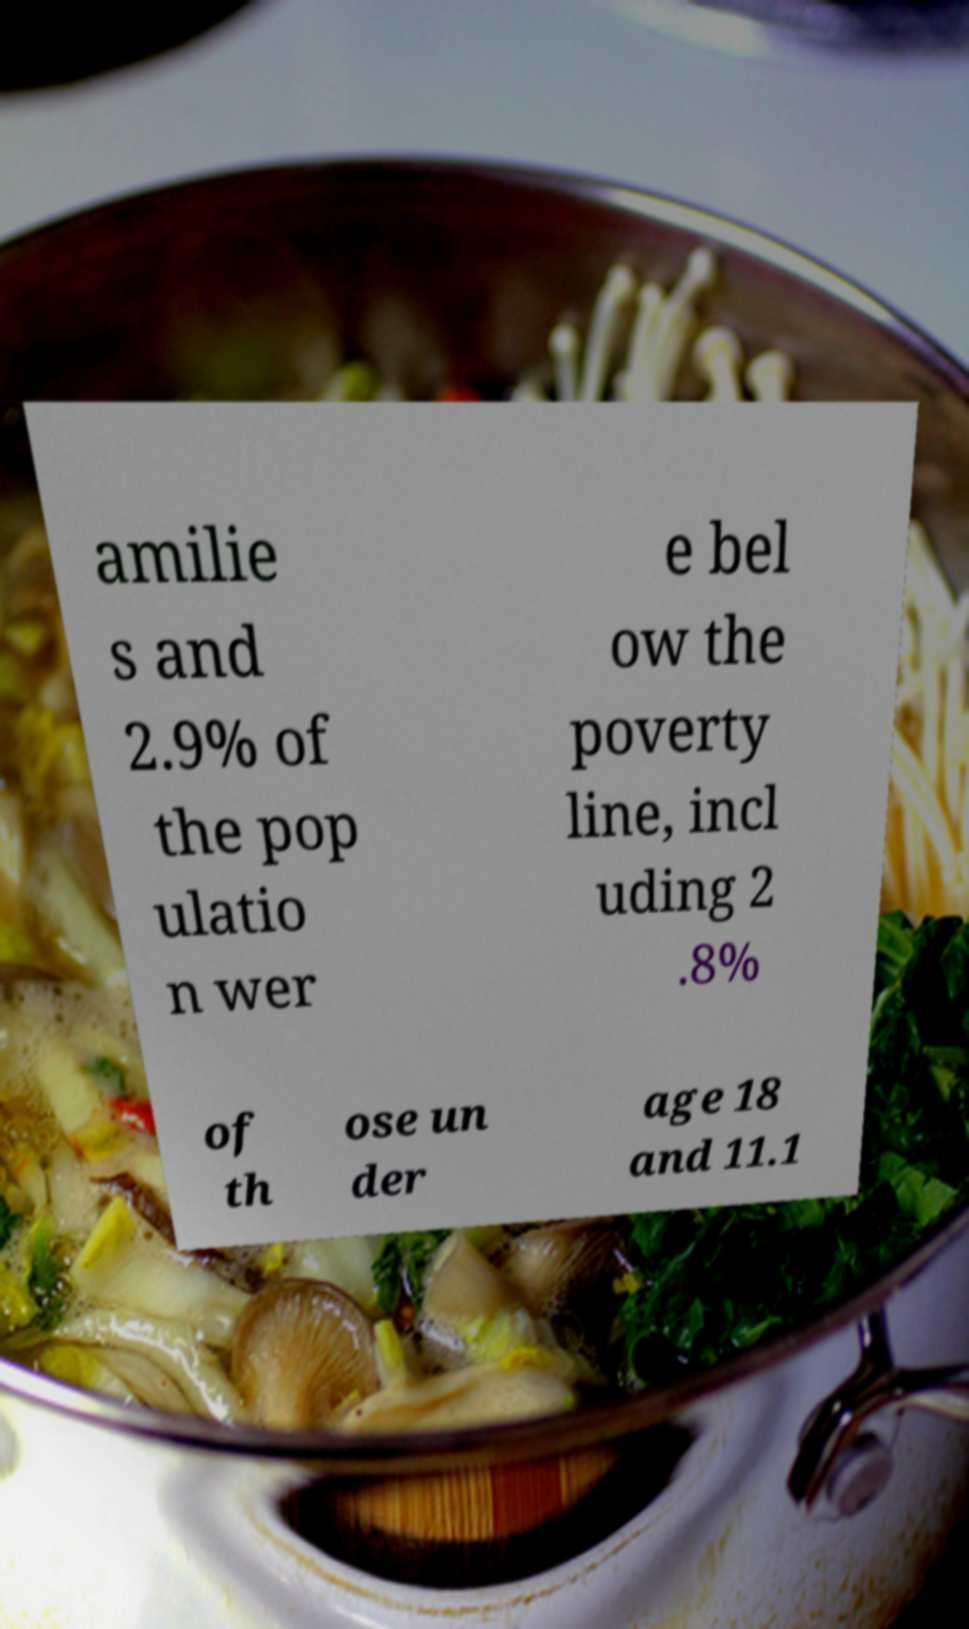Please identify and transcribe the text found in this image. amilie s and 2.9% of the pop ulatio n wer e bel ow the poverty line, incl uding 2 .8% of th ose un der age 18 and 11.1 